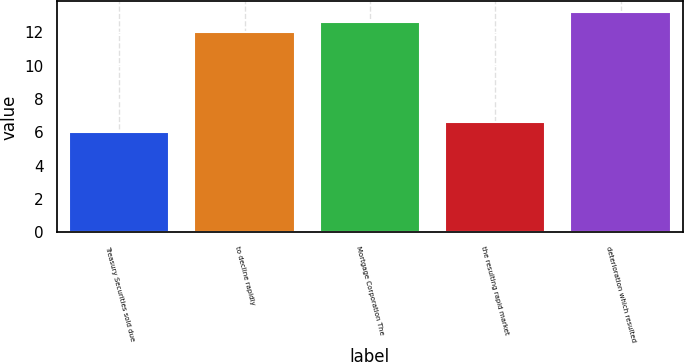<chart> <loc_0><loc_0><loc_500><loc_500><bar_chart><fcel>Treasury Securities sold due<fcel>to decline rapidly<fcel>Mortgage Corporation The<fcel>the resulting rapid market<fcel>deterioration which resulted<nl><fcel>6<fcel>12<fcel>12.6<fcel>6.6<fcel>13.2<nl></chart> 